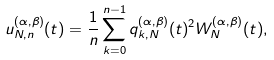<formula> <loc_0><loc_0><loc_500><loc_500>u _ { N , n } ^ { ( \alpha , \beta ) } ( t ) = \frac { 1 } { n } \sum _ { k = 0 } ^ { n - 1 } q _ { k , N } ^ { ( \alpha , \beta ) } ( t ) ^ { 2 } W _ { N } ^ { ( \alpha , \beta ) } ( t ) ,</formula> 